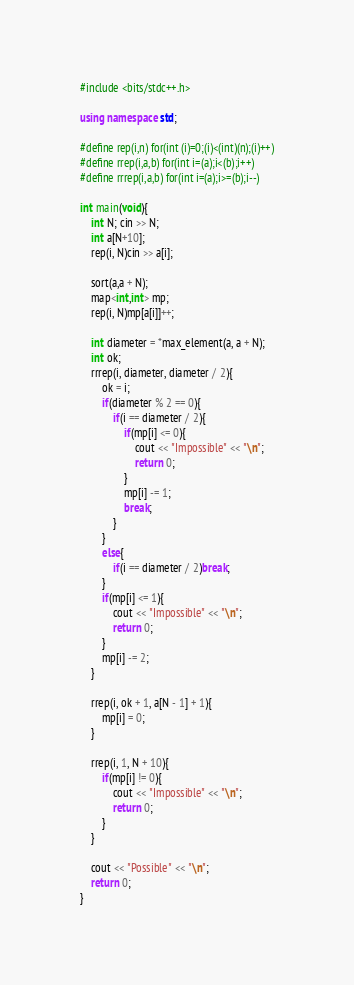Convert code to text. <code><loc_0><loc_0><loc_500><loc_500><_C++_>#include <bits/stdc++.h>

using namespace std;

#define rep(i,n) for(int (i)=0;(i)<(int)(n);(i)++)
#define rrep(i,a,b) for(int i=(a);i<(b);i++)
#define rrrep(i,a,b) for(int i=(a);i>=(b);i--)

int main(void){
    int N; cin >> N;
    int a[N+10];
    rep(i, N)cin >> a[i];

    sort(a,a + N);
    map<int,int> mp;
    rep(i, N)mp[a[i]]++;

    int diameter = *max_element(a, a + N);
    int ok;
    rrrep(i, diameter, diameter / 2){
        ok = i;
        if(diameter % 2 == 0){
            if(i == diameter / 2){
                if(mp[i] <= 0){
                    cout << "Impossible" << "\n";
                    return 0;
                }
                mp[i] -= 1;
                break;
            }
        }
        else{
            if(i == diameter / 2)break;
        }
        if(mp[i] <= 1){
            cout << "Impossible" << "\n";
            return 0;
        }
        mp[i] -= 2;
    }

    rrep(i, ok + 1, a[N - 1] + 1){
        mp[i] = 0;
    }

    rrep(i, 1, N + 10){
        if(mp[i] != 0){
            cout << "Impossible" << "\n";
            return 0;
        }
    }
    
    cout << "Possible" << "\n";
    return 0;
}
</code> 